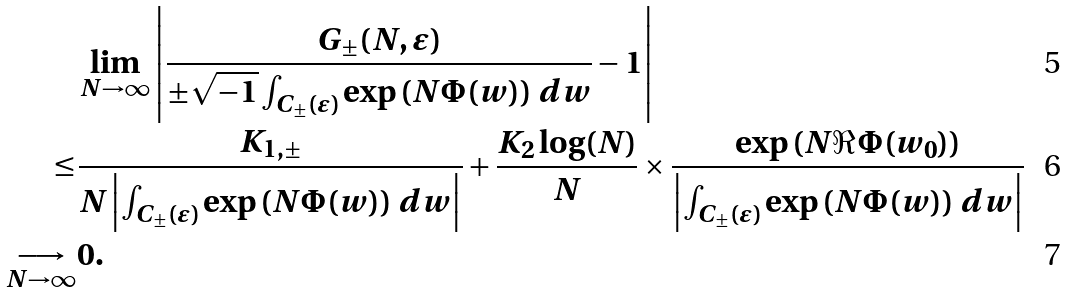Convert formula to latex. <formula><loc_0><loc_0><loc_500><loc_500>& \lim _ { N \to \infty } \left | \frac { G _ { \pm } ( N , \varepsilon ) } { \pm \sqrt { - 1 } \int _ { C _ { \pm } ( \varepsilon ) } \exp \left ( N \Phi ( w ) \right ) \, d w } - 1 \right | \\ \leq & \frac { K _ { 1 , \pm } } { N \left | \int _ { C _ { \pm } ( \varepsilon ) } \exp \left ( N \Phi ( w ) \right ) \, d w \right | } + \frac { K _ { 2 } \log ( N ) } { N } \times \frac { \exp \left ( N \Re \Phi ( w _ { 0 } ) \right ) } { \left | \int _ { C _ { \pm } ( \varepsilon ) } \exp \left ( N \Phi ( w ) \right ) \, d w \right | } \\ \underset { N \to \infty } { \longrightarrow } & 0 .</formula> 